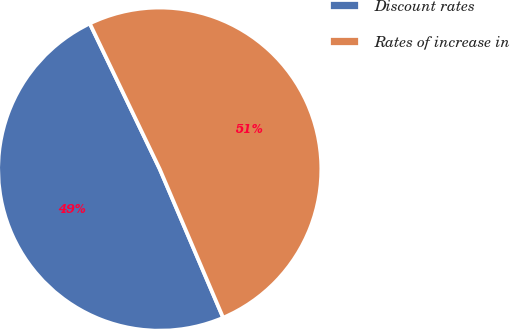<chart> <loc_0><loc_0><loc_500><loc_500><pie_chart><fcel>Discount rates<fcel>Rates of increase in<nl><fcel>49.29%<fcel>50.71%<nl></chart> 